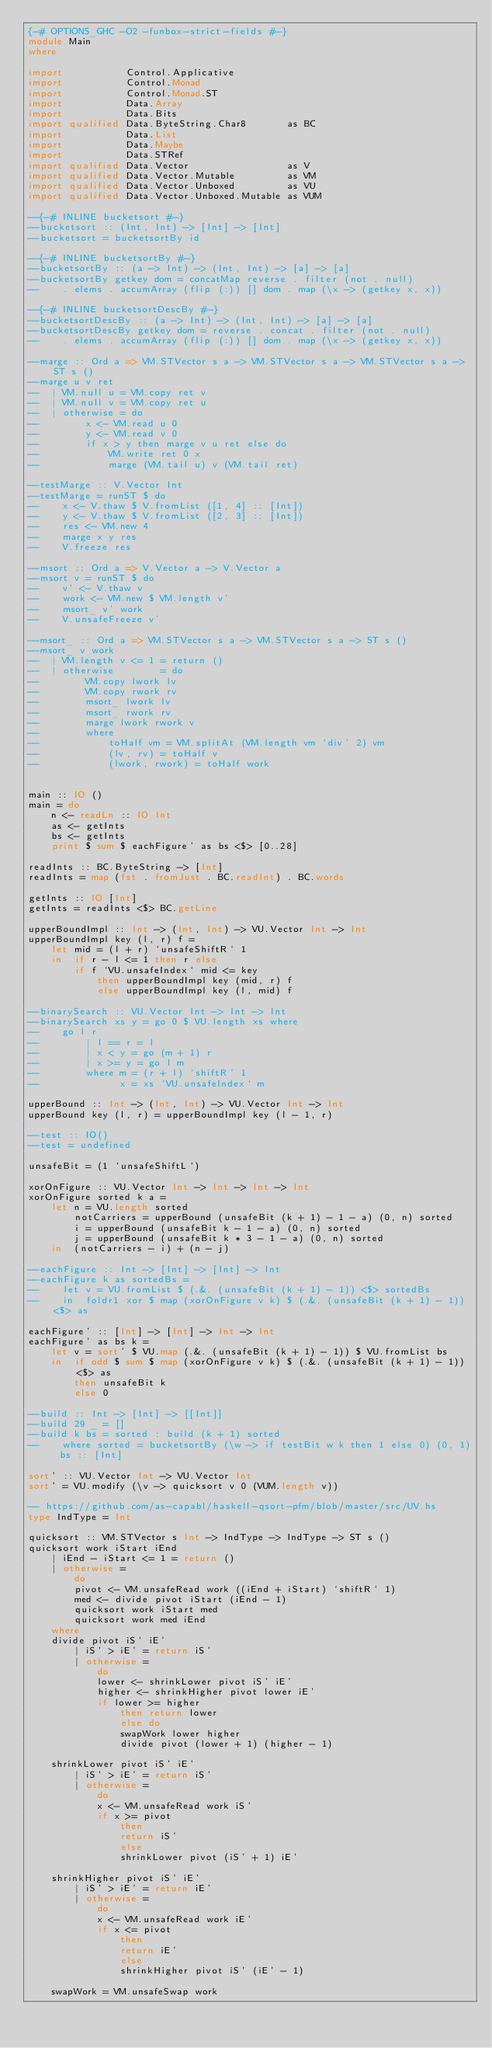Convert code to text. <code><loc_0><loc_0><loc_500><loc_500><_Haskell_>{-# OPTIONS_GHC -O2 -funbox-strict-fields #-}
module Main
where

import           Control.Applicative
import           Control.Monad
import           Control.Monad.ST
import           Data.Array
import           Data.Bits
import qualified Data.ByteString.Char8       as BC
import           Data.List
import           Data.Maybe
import           Data.STRef
import qualified Data.Vector                 as V
import qualified Data.Vector.Mutable         as VM
import qualified Data.Vector.Unboxed         as VU
import qualified Data.Vector.Unboxed.Mutable as VUM

--{-# INLINE bucketsort #-}
--bucketsort :: (Int, Int) -> [Int] -> [Int]
--bucketsort = bucketsortBy id

--{-# INLINE bucketsortBy #-}
--bucketsortBy :: (a -> Int) -> (Int, Int) -> [a] -> [a]
--bucketsortBy getkey dom = concatMap reverse . filter (not . null)
--    . elems . accumArray (flip (:)) [] dom . map (\x -> (getkey x, x))

--{-# INLINE bucketsortDescBy #-}
--bucketsortDescBy :: (a -> Int) -> (Int, Int) -> [a] -> [a]
--bucketsortDescBy getkey dom = reverse . concat . filter (not . null)
--    . elems . accumArray (flip (:)) [] dom . map (\x -> (getkey x, x))

--marge :: Ord a => VM.STVector s a -> VM.STVector s a -> VM.STVector s a -> ST s ()
--marge u v ret
--  | VM.null u = VM.copy ret v
--  | VM.null v = VM.copy ret u
--  | otherwise = do
--        x <- VM.read u 0
--        y <- VM.read v 0
--        if x > y then marge v u ret else do
--            VM.write ret 0 x
--            marge (VM.tail u) v (VM.tail ret)

--testMarge :: V.Vector Int
--testMarge = runST $ do
--    x <- V.thaw $ V.fromList ([1, 4] :: [Int])
--    y <- V.thaw $ V.fromList ([2, 3] :: [Int])
--    res <- VM.new 4
--    marge x y res
--    V.freeze res

--msort :: Ord a => V.Vector a -> V.Vector a
--msort v = runST $ do
--    v' <- V.thaw v
--    work <- VM.new $ VM.length v'
--    msort_ v' work
--    V.unsafeFreeze v'

--msort_ :: Ord a => VM.STVector s a -> VM.STVector s a -> ST s ()
--msort_ v work
--  | VM.length v <= 1 = return ()
--  | otherwise        = do
--        VM.copy lwork lv
--        VM.copy rwork rv
--        msort_ lwork lv
--        msort_ rwork rv
--        marge lwork rwork v
--        where
--            toHalf vm = VM.splitAt (VM.length vm `div` 2) vm
--            (lv, rv) = toHalf v
--            (lwork, rwork) = toHalf work


main :: IO ()
main = do
    n <- readLn :: IO Int
    as <- getInts
    bs <- getInts
    print $ sum $ eachFigure' as bs <$> [0..28]

readInts :: BC.ByteString -> [Int]
readInts = map (fst . fromJust . BC.readInt) . BC.words

getInts :: IO [Int]
getInts = readInts <$> BC.getLine

upperBoundImpl :: Int -> (Int, Int) -> VU.Vector Int -> Int
upperBoundImpl key (l, r) f =
    let mid = (l + r) `unsafeShiftR` 1
    in  if r - l <= 1 then r else
        if f `VU.unsafeIndex` mid <= key
            then upperBoundImpl key (mid, r) f
            else upperBoundImpl key (l, mid) f

--binarySearch :: VU.Vector Int -> Int -> Int
--binarySearch xs y = go 0 $ VU.length xs where
--    go l r
--        | l == r = l
--        | x < y = go (m + 1) r
--        | x >= y = go l m
--        where m = (r + l) `shiftR` 1
--              x = xs `VU.unsafeIndex` m

upperBound :: Int -> (Int, Int) -> VU.Vector Int -> Int
upperBound key (l, r) = upperBoundImpl key (l - 1, r)

--test :: IO()
--test = undefined

unsafeBit = (1 `unsafeShiftL`)

xorOnFigure :: VU.Vector Int -> Int -> Int -> Int
xorOnFigure sorted k a =
    let n = VU.length sorted
        notCarriers = upperBound (unsafeBit (k + 1) - 1 - a) (0, n) sorted
        i = upperBound (unsafeBit k - 1 - a) (0, n) sorted
        j = upperBound (unsafeBit k * 3 - 1 - a) (0, n) sorted
    in  (notCarriers - i) + (n - j)

--eachFigure :: Int -> [Int] -> [Int] -> Int
--eachFigure k as sortedBs =
--    let v = VU.fromList $ (.&. (unsafeBit (k + 1) - 1)) <$> sortedBs
--    in  foldr1 xor $ map (xorOnFigure v k) $ (.&. (unsafeBit (k + 1) - 1)) <$> as

eachFigure' :: [Int] -> [Int] -> Int -> Int
eachFigure' as bs k =
    let v = sort' $ VU.map (.&. (unsafeBit (k + 1) - 1)) $ VU.fromList bs
    in  if odd $ sum $ map (xorOnFigure v k) $ (.&. (unsafeBit (k + 1) - 1)) <$> as
        then unsafeBit k
        else 0

--build :: Int -> [Int] -> [[Int]]
--build 29 _ = []
--build k bs = sorted : build (k + 1) sorted
--    where sorted = bucketsortBy (\w -> if testBit w k then 1 else 0) (0, 1) bs :: [Int]

sort' :: VU.Vector Int -> VU.Vector Int
sort' = VU.modify (\v -> quicksort v 0 (VUM.length v))

-- https://github.com/as-capabl/haskell-qsort-pfm/blob/master/src/UV.hs
type IndType = Int

quicksort :: VM.STVector s Int -> IndType -> IndType -> ST s ()
quicksort work iStart iEnd
    | iEnd - iStart <= 1 = return ()
    | otherwise =
        do
        pivot <- VM.unsafeRead work ((iEnd + iStart) `shiftR` 1)
        med <- divide pivot iStart (iEnd - 1)
        quicksort work iStart med
        quicksort work med iEnd
    where
    divide pivot iS' iE'
        | iS' > iE' = return iS'
        | otherwise =
            do
            lower <- shrinkLower pivot iS' iE'
            higher <- shrinkHigher pivot lower iE'
            if lower >= higher
                then return lower
                else do
                swapWork lower higher
                divide pivot (lower + 1) (higher - 1)

    shrinkLower pivot iS' iE'
        | iS' > iE' = return iS'
        | otherwise =
            do
            x <- VM.unsafeRead work iS'
            if x >= pivot
                then
                return iS'
                else
                shrinkLower pivot (iS' + 1) iE'

    shrinkHigher pivot iS' iE'
        | iS' > iE' = return iE'
        | otherwise =
            do
            x <- VM.unsafeRead work iE'
            if x <= pivot
                then
                return iE'
                else
                shrinkHigher pivot iS' (iE' - 1)

    swapWork = VM.unsafeSwap work
</code> 